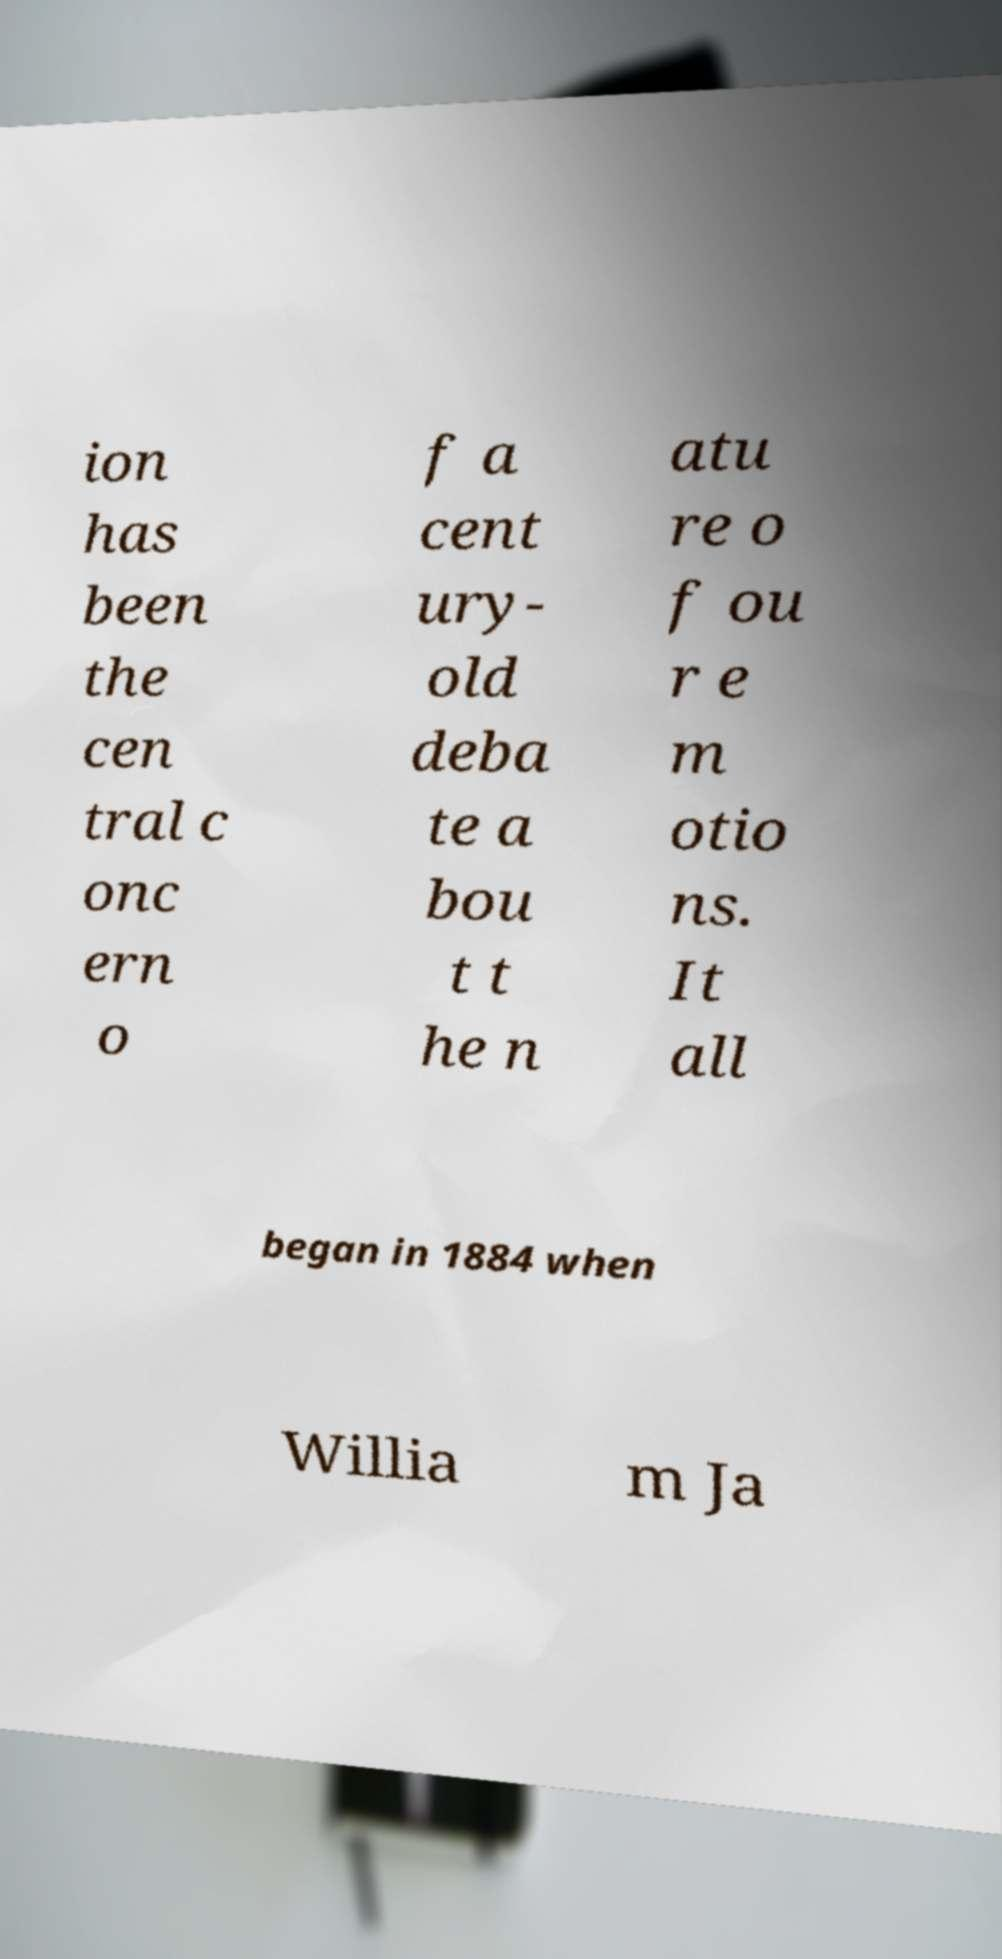I need the written content from this picture converted into text. Can you do that? ion has been the cen tral c onc ern o f a cent ury- old deba te a bou t t he n atu re o f ou r e m otio ns. It all began in 1884 when Willia m Ja 